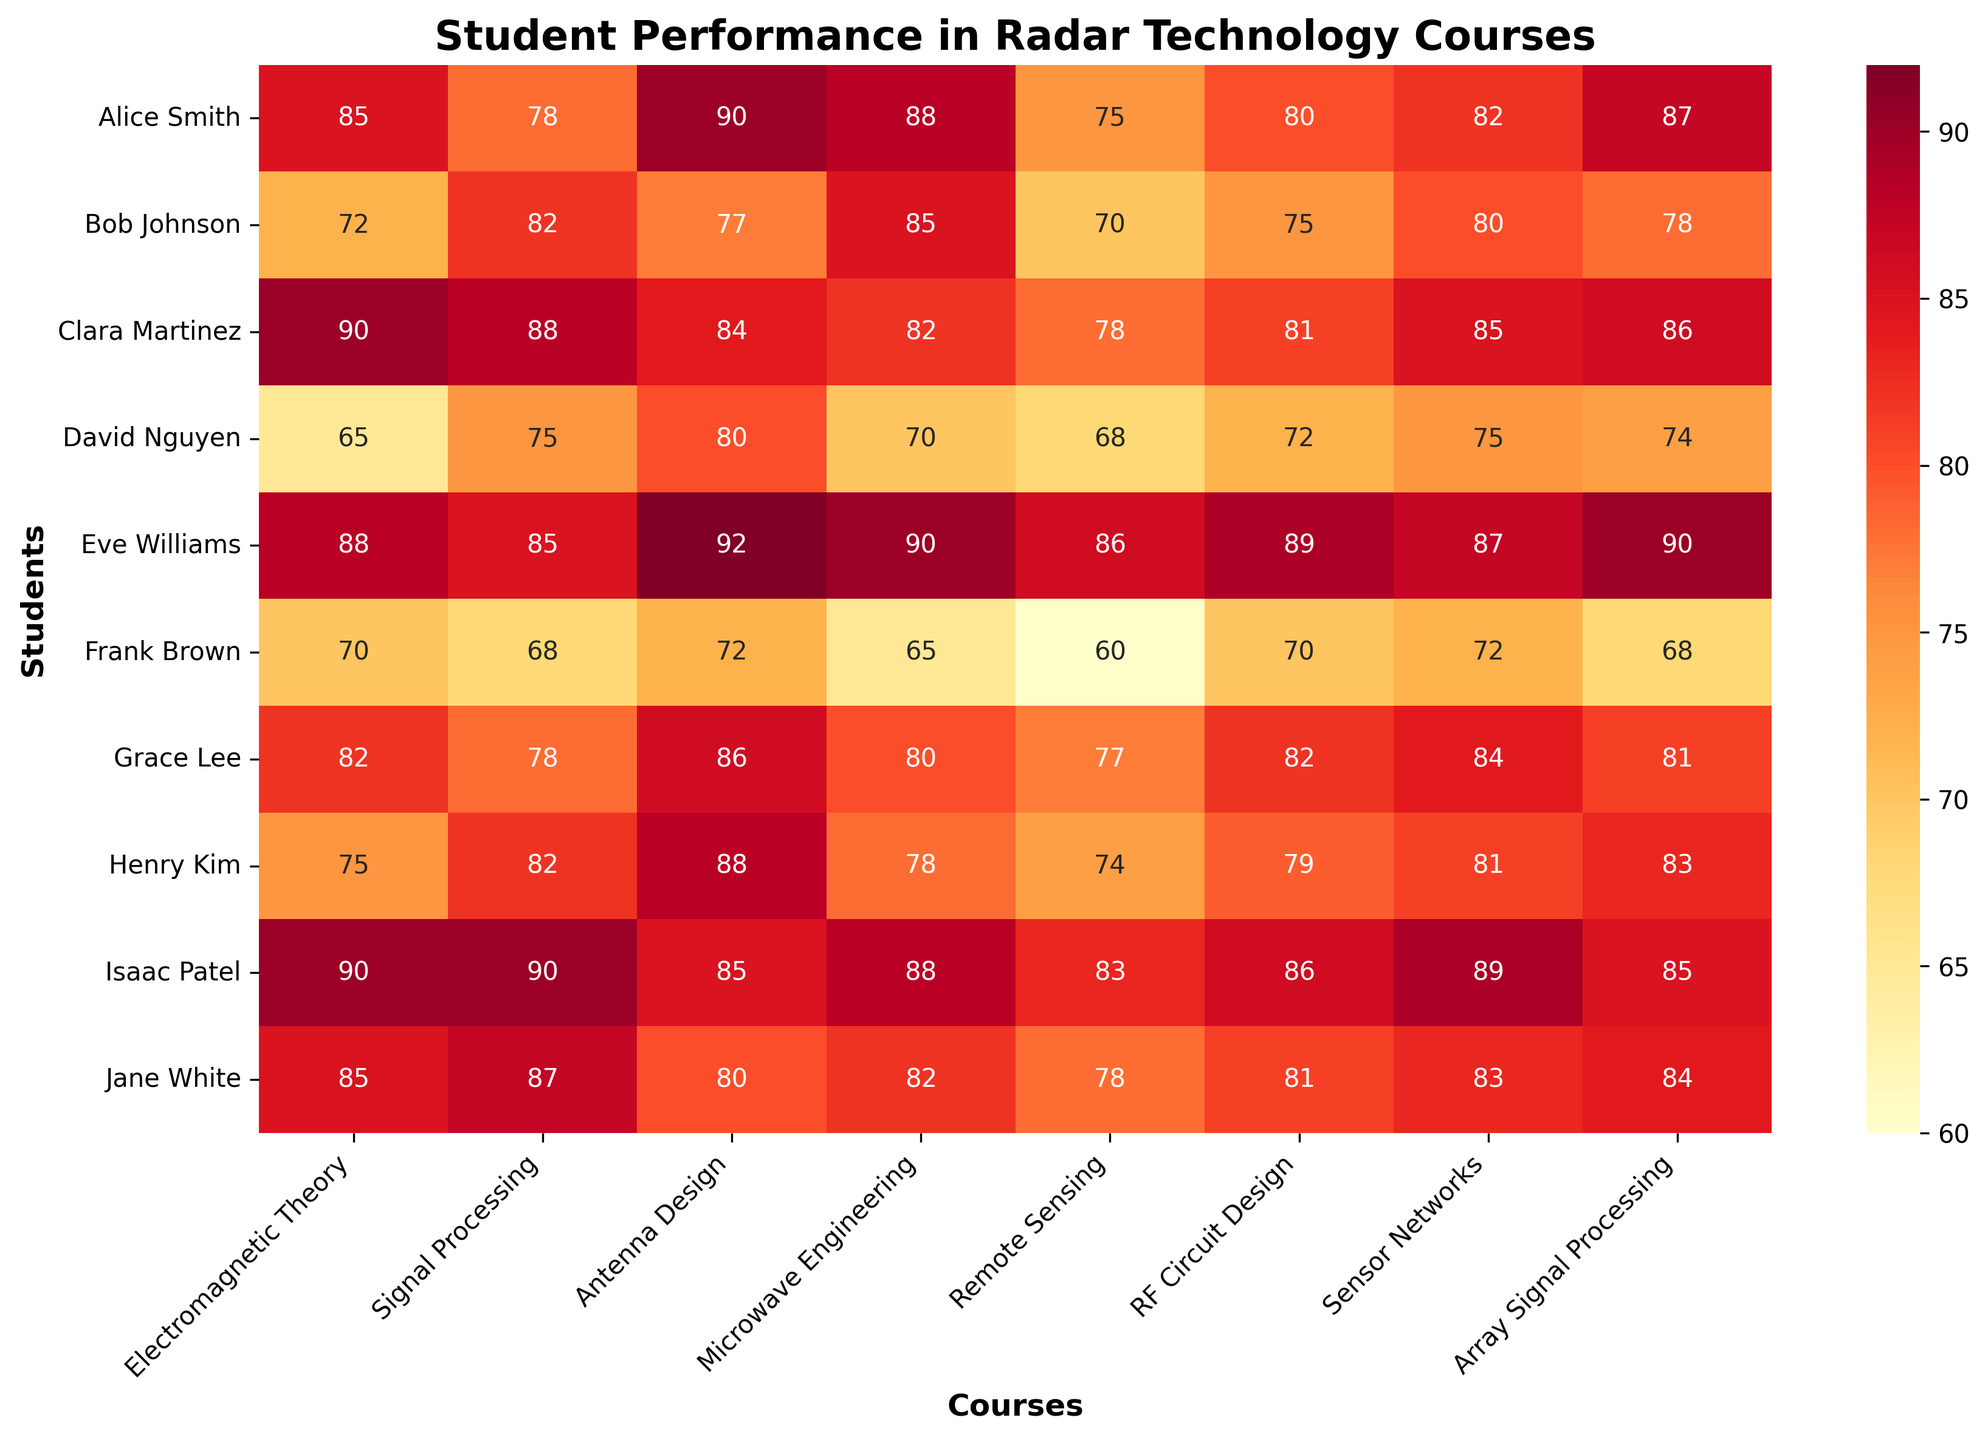What's the highest score received by any student in 'Antenna Design'? To find the highest score in 'Antenna Design', scan the 'Antenna Design' column for the maximum value. The values are 90, 77, 84, 80, 92, 72, 86, 88, 85, and 80. The highest value is 92.
Answer: 92 Which student has the lowest score in 'Microwave Engineering'? To identify the student with the lowest score in 'Microwave Engineering', check the 'Microwave Engineering' column. The values are 88, 85, 82, 70, 90, 65, 80, 78, 88, and 82. The lowest score is 65, which belongs to Frank Brown.
Answer: Frank Brown What's the average score of David Nguyen across all courses? To calculate David Nguyen's average score across all courses, sum his scores: 65, 75, 80, 70, 68, 72, 75, 74, which total 579. There are 8 courses, so the average is 579/8 = 72.375.
Answer: 72.375 How does Grace Lee's performance in 'Antenna Design' compare to Alice Smith's in the same course? Compare Grace Lee's score of 86 in 'Antenna Design' with Alice Smith's score of 90 in the same course. Since 86 is less than 90, Grace's score is lower.
Answer: Alice Smith scored higher Who scored higher in 'Sensor Networks': Eve Williams or Henry Kim? Compare Eve Williams' score of 87 in 'Sensor Networks' with Henry Kim's score of 81. Since 87 is greater than 81, Eve Williams scored higher.
Answer: Eve Williams What is the range of scores in 'Electromagnetic Theory'? To find the range, determine the maximum and minimum scores in 'Electromagnetic Theory'. The scores are 85, 72, 90, 65, 88, 70, 82, 75, 90, and 85. The range is 90 (max) - 65 (min) = 25.
Answer: 25 Which course has the highest average score? Compute the average score for each course. Electromagnetic Theory: (85+72+90+65+88+70+82+75+90+85)/10 = 80.7, Signal Processing: 80.3, Antenna Design: 83.4, Microwave Engineering: 79.8, Remote Sensing: 74.9, RF Circuit Design: 79.5, Sensor Networks: 81.8, Array Signal Processing: 83.2. 'Antenna Design' has the highest average score of 83.4.
Answer: Antenna Design What is the most common score range for 'Remote Sensing'? Examine the 'Remote Sensing' column: 75, 70, 78, 68, 86, 60, 77, 74, 83, and 78. Common score ranges (buckets) could be 60-69, 70-79, 80-89, etc. The range 70-79 appears most frequently, with scores 70, 78, 77, 74, and 78.
Answer: 70-79 Which student has a more balanced performance, Clara Martinez or Isaac Patel? (consider the variance of their scores as a measure of balance) Calculate the variance of scores for Clara Martinez and Isaac Patel. Clara Martinez's scores: 90, 88, 84, 82, 78, 81, 85, 86; variance ≈ 15.96. Isaac Patel's scores: 90, 90, 85, 88, 83, 86, 89, 85; variance ≈ 5.18. Isaac Patel has a lower variance, suggesting a more balanced performance.
Answer: Isaac Patel 